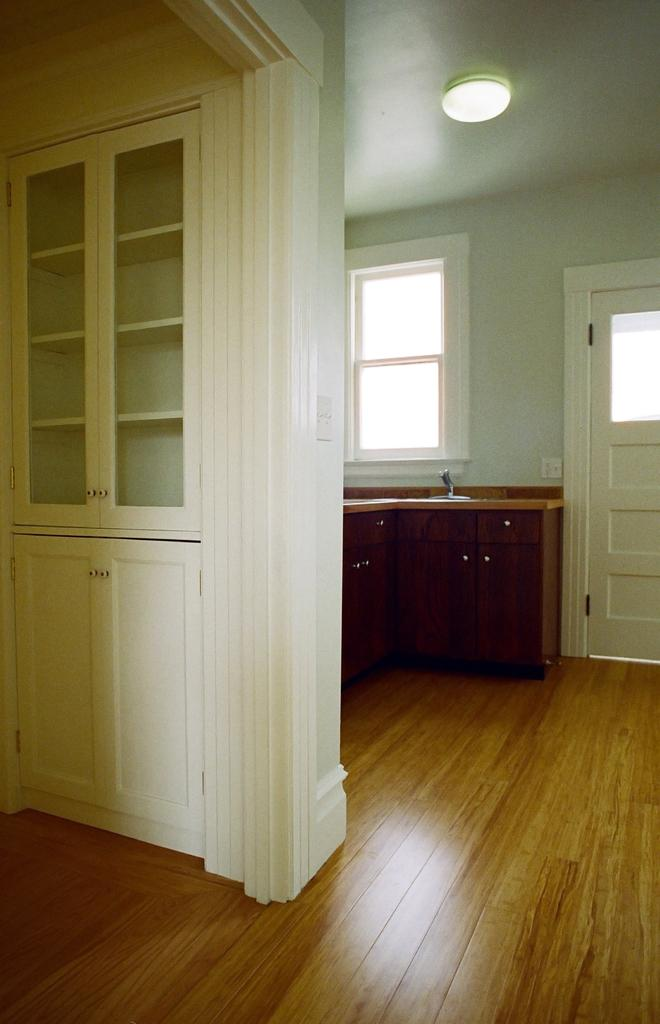What type of surface is visible in the image? The image contains a floor. What other architectural elements can be seen in the image? There is a wall and doors in the image. What is the purpose of the platform in the image? A kitchen platform is present in the image, which suggests it is a kitchen setting. What can be seen in the background of the image? There is a window, the roof, and a light visible in the background of the image. How many apples are on the floor in the image? There are no apples present in the image. What is the distance between the wall and the window in the image? The provided facts do not include any information about the distance between the wall and the window, so it cannot be determined from the image. 